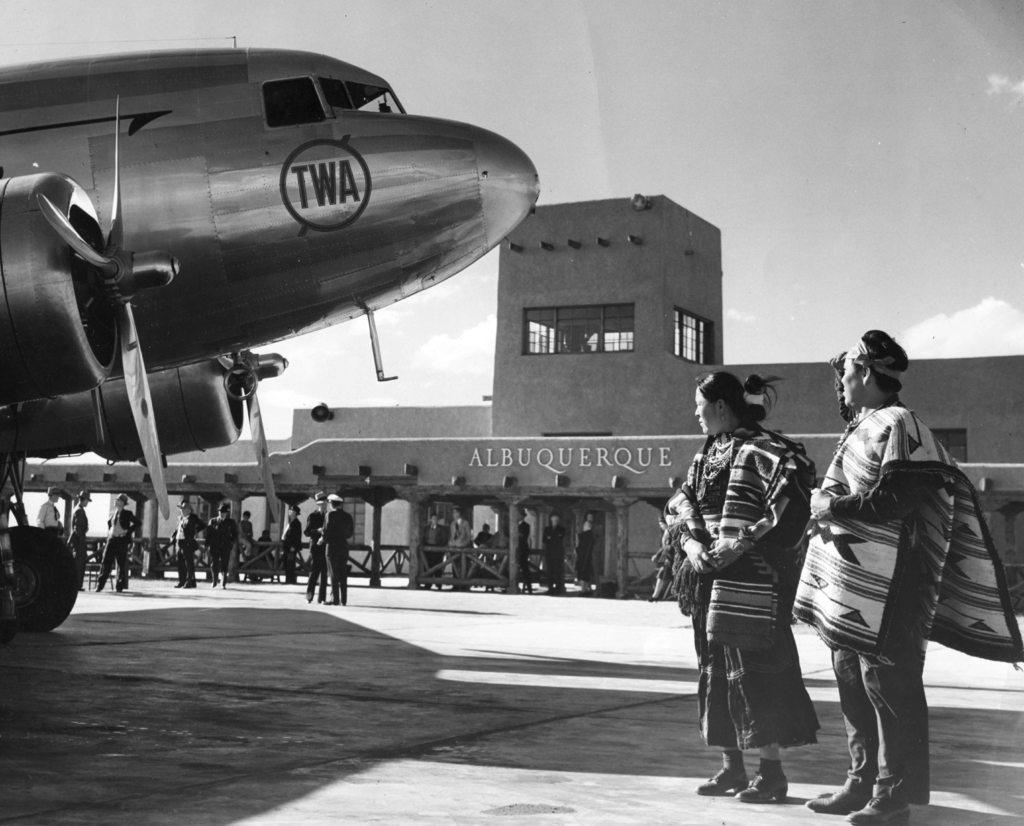Could you give a brief overview of what you see in this image? On the right side of the image two persons are standing. On the left side of the image an aeroplane and some persons are there. In the center of the image a building is present. At the top of the image sky is there. At the bottom of the image ground is there. 